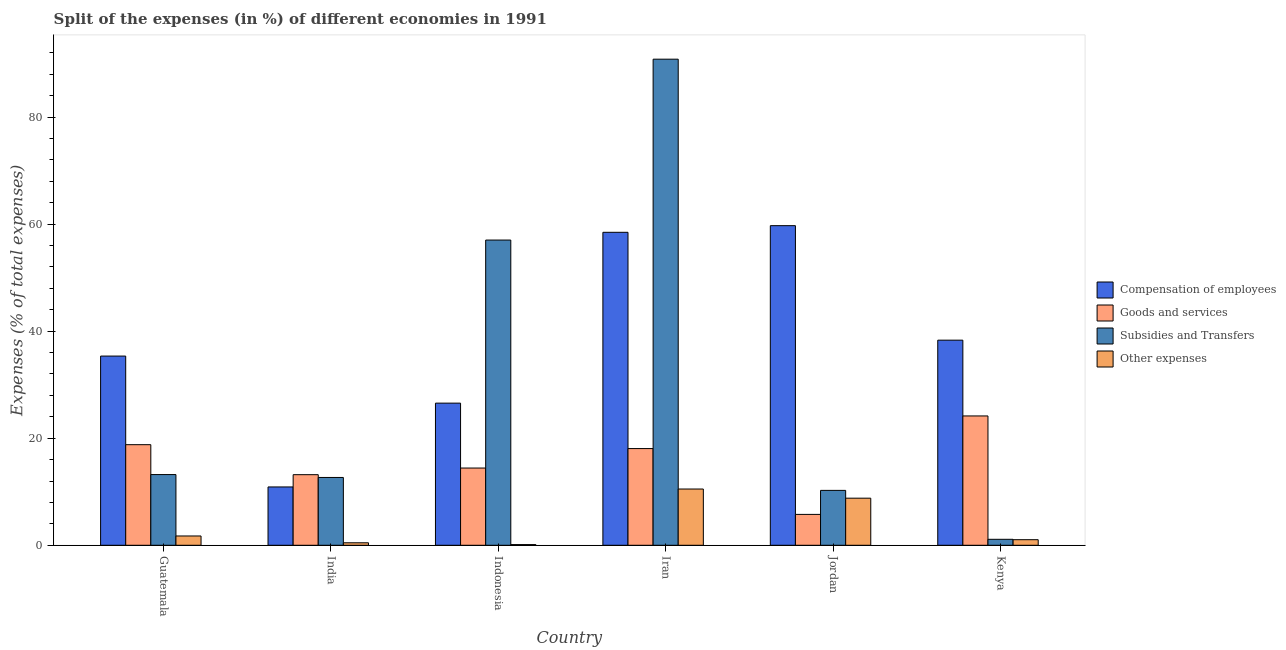How many groups of bars are there?
Provide a short and direct response. 6. How many bars are there on the 1st tick from the left?
Offer a terse response. 4. How many bars are there on the 3rd tick from the right?
Keep it short and to the point. 4. What is the label of the 6th group of bars from the left?
Your response must be concise. Kenya. What is the percentage of amount spent on subsidies in Guatemala?
Give a very brief answer. 13.21. Across all countries, what is the maximum percentage of amount spent on goods and services?
Your answer should be compact. 24.16. Across all countries, what is the minimum percentage of amount spent on other expenses?
Provide a succinct answer. 0.13. In which country was the percentage of amount spent on compensation of employees maximum?
Keep it short and to the point. Jordan. In which country was the percentage of amount spent on subsidies minimum?
Your response must be concise. Kenya. What is the total percentage of amount spent on other expenses in the graph?
Provide a succinct answer. 22.68. What is the difference between the percentage of amount spent on subsidies in Jordan and that in Kenya?
Your response must be concise. 9.14. What is the difference between the percentage of amount spent on goods and services in Indonesia and the percentage of amount spent on other expenses in Jordan?
Your response must be concise. 5.63. What is the average percentage of amount spent on subsidies per country?
Offer a terse response. 30.84. What is the difference between the percentage of amount spent on subsidies and percentage of amount spent on other expenses in Iran?
Your response must be concise. 80.3. What is the ratio of the percentage of amount spent on compensation of employees in Guatemala to that in Indonesia?
Offer a terse response. 1.33. Is the difference between the percentage of amount spent on goods and services in Indonesia and Jordan greater than the difference between the percentage of amount spent on compensation of employees in Indonesia and Jordan?
Provide a succinct answer. Yes. What is the difference between the highest and the second highest percentage of amount spent on other expenses?
Ensure brevity in your answer.  1.71. What is the difference between the highest and the lowest percentage of amount spent on compensation of employees?
Make the answer very short. 48.81. In how many countries, is the percentage of amount spent on other expenses greater than the average percentage of amount spent on other expenses taken over all countries?
Ensure brevity in your answer.  2. Is it the case that in every country, the sum of the percentage of amount spent on compensation of employees and percentage of amount spent on subsidies is greater than the sum of percentage of amount spent on other expenses and percentage of amount spent on goods and services?
Offer a very short reply. No. What does the 1st bar from the left in India represents?
Provide a succinct answer. Compensation of employees. What does the 3rd bar from the right in Indonesia represents?
Offer a very short reply. Goods and services. Is it the case that in every country, the sum of the percentage of amount spent on compensation of employees and percentage of amount spent on goods and services is greater than the percentage of amount spent on subsidies?
Provide a succinct answer. No. How many bars are there?
Make the answer very short. 24. Are all the bars in the graph horizontal?
Your response must be concise. No. What is the difference between two consecutive major ticks on the Y-axis?
Keep it short and to the point. 20. Does the graph contain any zero values?
Ensure brevity in your answer.  No. Does the graph contain grids?
Offer a very short reply. No. Where does the legend appear in the graph?
Provide a short and direct response. Center right. How many legend labels are there?
Your response must be concise. 4. How are the legend labels stacked?
Your response must be concise. Vertical. What is the title of the graph?
Give a very brief answer. Split of the expenses (in %) of different economies in 1991. Does "Source data assessment" appear as one of the legend labels in the graph?
Make the answer very short. No. What is the label or title of the X-axis?
Ensure brevity in your answer.  Country. What is the label or title of the Y-axis?
Keep it short and to the point. Expenses (% of total expenses). What is the Expenses (% of total expenses) in Compensation of employees in Guatemala?
Give a very brief answer. 35.34. What is the Expenses (% of total expenses) of Goods and services in Guatemala?
Your response must be concise. 18.79. What is the Expenses (% of total expenses) of Subsidies and Transfers in Guatemala?
Offer a terse response. 13.21. What is the Expenses (% of total expenses) in Other expenses in Guatemala?
Keep it short and to the point. 1.74. What is the Expenses (% of total expenses) of Compensation of employees in India?
Your response must be concise. 10.9. What is the Expenses (% of total expenses) of Goods and services in India?
Give a very brief answer. 13.19. What is the Expenses (% of total expenses) in Subsidies and Transfers in India?
Provide a succinct answer. 12.67. What is the Expenses (% of total expenses) in Other expenses in India?
Keep it short and to the point. 0.46. What is the Expenses (% of total expenses) of Compensation of employees in Indonesia?
Keep it short and to the point. 26.55. What is the Expenses (% of total expenses) of Goods and services in Indonesia?
Give a very brief answer. 14.43. What is the Expenses (% of total expenses) in Subsidies and Transfers in Indonesia?
Ensure brevity in your answer.  57.02. What is the Expenses (% of total expenses) in Other expenses in Indonesia?
Make the answer very short. 0.13. What is the Expenses (% of total expenses) in Compensation of employees in Iran?
Provide a succinct answer. 58.46. What is the Expenses (% of total expenses) of Goods and services in Iran?
Provide a succinct answer. 18.07. What is the Expenses (% of total expenses) of Subsidies and Transfers in Iran?
Ensure brevity in your answer.  90.8. What is the Expenses (% of total expenses) in Other expenses in Iran?
Provide a succinct answer. 10.51. What is the Expenses (% of total expenses) in Compensation of employees in Jordan?
Offer a terse response. 59.7. What is the Expenses (% of total expenses) in Goods and services in Jordan?
Offer a terse response. 5.77. What is the Expenses (% of total expenses) in Subsidies and Transfers in Jordan?
Provide a short and direct response. 10.25. What is the Expenses (% of total expenses) of Other expenses in Jordan?
Your response must be concise. 8.8. What is the Expenses (% of total expenses) in Compensation of employees in Kenya?
Make the answer very short. 38.32. What is the Expenses (% of total expenses) in Goods and services in Kenya?
Your answer should be compact. 24.16. What is the Expenses (% of total expenses) of Subsidies and Transfers in Kenya?
Provide a short and direct response. 1.12. What is the Expenses (% of total expenses) of Other expenses in Kenya?
Give a very brief answer. 1.04. Across all countries, what is the maximum Expenses (% of total expenses) in Compensation of employees?
Make the answer very short. 59.7. Across all countries, what is the maximum Expenses (% of total expenses) of Goods and services?
Make the answer very short. 24.16. Across all countries, what is the maximum Expenses (% of total expenses) in Subsidies and Transfers?
Offer a terse response. 90.8. Across all countries, what is the maximum Expenses (% of total expenses) of Other expenses?
Provide a short and direct response. 10.51. Across all countries, what is the minimum Expenses (% of total expenses) in Compensation of employees?
Provide a short and direct response. 10.9. Across all countries, what is the minimum Expenses (% of total expenses) of Goods and services?
Your answer should be very brief. 5.77. Across all countries, what is the minimum Expenses (% of total expenses) of Subsidies and Transfers?
Your response must be concise. 1.12. Across all countries, what is the minimum Expenses (% of total expenses) of Other expenses?
Your answer should be compact. 0.13. What is the total Expenses (% of total expenses) in Compensation of employees in the graph?
Provide a short and direct response. 229.28. What is the total Expenses (% of total expenses) in Goods and services in the graph?
Your response must be concise. 94.4. What is the total Expenses (% of total expenses) in Subsidies and Transfers in the graph?
Give a very brief answer. 185.06. What is the total Expenses (% of total expenses) of Other expenses in the graph?
Your answer should be very brief. 22.68. What is the difference between the Expenses (% of total expenses) of Compensation of employees in Guatemala and that in India?
Make the answer very short. 24.45. What is the difference between the Expenses (% of total expenses) of Goods and services in Guatemala and that in India?
Your answer should be very brief. 5.6. What is the difference between the Expenses (% of total expenses) of Subsidies and Transfers in Guatemala and that in India?
Your response must be concise. 0.54. What is the difference between the Expenses (% of total expenses) of Other expenses in Guatemala and that in India?
Provide a succinct answer. 1.27. What is the difference between the Expenses (% of total expenses) of Compensation of employees in Guatemala and that in Indonesia?
Make the answer very short. 8.79. What is the difference between the Expenses (% of total expenses) in Goods and services in Guatemala and that in Indonesia?
Provide a short and direct response. 4.36. What is the difference between the Expenses (% of total expenses) of Subsidies and Transfers in Guatemala and that in Indonesia?
Ensure brevity in your answer.  -43.81. What is the difference between the Expenses (% of total expenses) of Other expenses in Guatemala and that in Indonesia?
Make the answer very short. 1.61. What is the difference between the Expenses (% of total expenses) of Compensation of employees in Guatemala and that in Iran?
Offer a terse response. -23.12. What is the difference between the Expenses (% of total expenses) in Goods and services in Guatemala and that in Iran?
Make the answer very short. 0.73. What is the difference between the Expenses (% of total expenses) in Subsidies and Transfers in Guatemala and that in Iran?
Your answer should be very brief. -77.6. What is the difference between the Expenses (% of total expenses) of Other expenses in Guatemala and that in Iran?
Offer a very short reply. -8.77. What is the difference between the Expenses (% of total expenses) in Compensation of employees in Guatemala and that in Jordan?
Give a very brief answer. -24.36. What is the difference between the Expenses (% of total expenses) in Goods and services in Guatemala and that in Jordan?
Offer a terse response. 13.02. What is the difference between the Expenses (% of total expenses) in Subsidies and Transfers in Guatemala and that in Jordan?
Keep it short and to the point. 2.95. What is the difference between the Expenses (% of total expenses) in Other expenses in Guatemala and that in Jordan?
Make the answer very short. -7.06. What is the difference between the Expenses (% of total expenses) in Compensation of employees in Guatemala and that in Kenya?
Offer a very short reply. -2.97. What is the difference between the Expenses (% of total expenses) of Goods and services in Guatemala and that in Kenya?
Provide a short and direct response. -5.37. What is the difference between the Expenses (% of total expenses) of Subsidies and Transfers in Guatemala and that in Kenya?
Give a very brief answer. 12.09. What is the difference between the Expenses (% of total expenses) in Other expenses in Guatemala and that in Kenya?
Offer a very short reply. 0.7. What is the difference between the Expenses (% of total expenses) in Compensation of employees in India and that in Indonesia?
Give a very brief answer. -15.66. What is the difference between the Expenses (% of total expenses) of Goods and services in India and that in Indonesia?
Give a very brief answer. -1.24. What is the difference between the Expenses (% of total expenses) in Subsidies and Transfers in India and that in Indonesia?
Offer a terse response. -44.35. What is the difference between the Expenses (% of total expenses) in Other expenses in India and that in Indonesia?
Keep it short and to the point. 0.33. What is the difference between the Expenses (% of total expenses) of Compensation of employees in India and that in Iran?
Ensure brevity in your answer.  -47.57. What is the difference between the Expenses (% of total expenses) of Goods and services in India and that in Iran?
Provide a short and direct response. -4.88. What is the difference between the Expenses (% of total expenses) of Subsidies and Transfers in India and that in Iran?
Provide a succinct answer. -78.14. What is the difference between the Expenses (% of total expenses) in Other expenses in India and that in Iran?
Your answer should be very brief. -10.05. What is the difference between the Expenses (% of total expenses) of Compensation of employees in India and that in Jordan?
Your answer should be very brief. -48.81. What is the difference between the Expenses (% of total expenses) of Goods and services in India and that in Jordan?
Your response must be concise. 7.42. What is the difference between the Expenses (% of total expenses) in Subsidies and Transfers in India and that in Jordan?
Offer a very short reply. 2.42. What is the difference between the Expenses (% of total expenses) of Other expenses in India and that in Jordan?
Provide a short and direct response. -8.34. What is the difference between the Expenses (% of total expenses) of Compensation of employees in India and that in Kenya?
Your answer should be compact. -27.42. What is the difference between the Expenses (% of total expenses) of Goods and services in India and that in Kenya?
Offer a terse response. -10.97. What is the difference between the Expenses (% of total expenses) in Subsidies and Transfers in India and that in Kenya?
Provide a short and direct response. 11.55. What is the difference between the Expenses (% of total expenses) in Other expenses in India and that in Kenya?
Make the answer very short. -0.58. What is the difference between the Expenses (% of total expenses) of Compensation of employees in Indonesia and that in Iran?
Give a very brief answer. -31.91. What is the difference between the Expenses (% of total expenses) in Goods and services in Indonesia and that in Iran?
Give a very brief answer. -3.64. What is the difference between the Expenses (% of total expenses) of Subsidies and Transfers in Indonesia and that in Iran?
Your response must be concise. -33.79. What is the difference between the Expenses (% of total expenses) of Other expenses in Indonesia and that in Iran?
Your response must be concise. -10.38. What is the difference between the Expenses (% of total expenses) of Compensation of employees in Indonesia and that in Jordan?
Give a very brief answer. -33.15. What is the difference between the Expenses (% of total expenses) in Goods and services in Indonesia and that in Jordan?
Give a very brief answer. 8.66. What is the difference between the Expenses (% of total expenses) of Subsidies and Transfers in Indonesia and that in Jordan?
Offer a very short reply. 46.76. What is the difference between the Expenses (% of total expenses) of Other expenses in Indonesia and that in Jordan?
Ensure brevity in your answer.  -8.67. What is the difference between the Expenses (% of total expenses) in Compensation of employees in Indonesia and that in Kenya?
Offer a very short reply. -11.76. What is the difference between the Expenses (% of total expenses) in Goods and services in Indonesia and that in Kenya?
Your answer should be very brief. -9.73. What is the difference between the Expenses (% of total expenses) in Subsidies and Transfers in Indonesia and that in Kenya?
Make the answer very short. 55.9. What is the difference between the Expenses (% of total expenses) of Other expenses in Indonesia and that in Kenya?
Your answer should be compact. -0.91. What is the difference between the Expenses (% of total expenses) of Compensation of employees in Iran and that in Jordan?
Offer a terse response. -1.24. What is the difference between the Expenses (% of total expenses) of Goods and services in Iran and that in Jordan?
Make the answer very short. 12.3. What is the difference between the Expenses (% of total expenses) of Subsidies and Transfers in Iran and that in Jordan?
Offer a terse response. 80.55. What is the difference between the Expenses (% of total expenses) in Other expenses in Iran and that in Jordan?
Ensure brevity in your answer.  1.71. What is the difference between the Expenses (% of total expenses) of Compensation of employees in Iran and that in Kenya?
Ensure brevity in your answer.  20.15. What is the difference between the Expenses (% of total expenses) in Goods and services in Iran and that in Kenya?
Offer a very short reply. -6.09. What is the difference between the Expenses (% of total expenses) in Subsidies and Transfers in Iran and that in Kenya?
Offer a terse response. 89.69. What is the difference between the Expenses (% of total expenses) in Other expenses in Iran and that in Kenya?
Offer a very short reply. 9.47. What is the difference between the Expenses (% of total expenses) of Compensation of employees in Jordan and that in Kenya?
Your answer should be very brief. 21.39. What is the difference between the Expenses (% of total expenses) of Goods and services in Jordan and that in Kenya?
Give a very brief answer. -18.39. What is the difference between the Expenses (% of total expenses) of Subsidies and Transfers in Jordan and that in Kenya?
Your response must be concise. 9.14. What is the difference between the Expenses (% of total expenses) in Other expenses in Jordan and that in Kenya?
Your response must be concise. 7.76. What is the difference between the Expenses (% of total expenses) of Compensation of employees in Guatemala and the Expenses (% of total expenses) of Goods and services in India?
Ensure brevity in your answer.  22.16. What is the difference between the Expenses (% of total expenses) of Compensation of employees in Guatemala and the Expenses (% of total expenses) of Subsidies and Transfers in India?
Offer a terse response. 22.68. What is the difference between the Expenses (% of total expenses) of Compensation of employees in Guatemala and the Expenses (% of total expenses) of Other expenses in India?
Provide a succinct answer. 34.88. What is the difference between the Expenses (% of total expenses) in Goods and services in Guatemala and the Expenses (% of total expenses) in Subsidies and Transfers in India?
Keep it short and to the point. 6.12. What is the difference between the Expenses (% of total expenses) in Goods and services in Guatemala and the Expenses (% of total expenses) in Other expenses in India?
Ensure brevity in your answer.  18.33. What is the difference between the Expenses (% of total expenses) in Subsidies and Transfers in Guatemala and the Expenses (% of total expenses) in Other expenses in India?
Your answer should be compact. 12.74. What is the difference between the Expenses (% of total expenses) in Compensation of employees in Guatemala and the Expenses (% of total expenses) in Goods and services in Indonesia?
Provide a succinct answer. 20.92. What is the difference between the Expenses (% of total expenses) in Compensation of employees in Guatemala and the Expenses (% of total expenses) in Subsidies and Transfers in Indonesia?
Offer a very short reply. -21.67. What is the difference between the Expenses (% of total expenses) of Compensation of employees in Guatemala and the Expenses (% of total expenses) of Other expenses in Indonesia?
Ensure brevity in your answer.  35.22. What is the difference between the Expenses (% of total expenses) of Goods and services in Guatemala and the Expenses (% of total expenses) of Subsidies and Transfers in Indonesia?
Your answer should be compact. -38.22. What is the difference between the Expenses (% of total expenses) in Goods and services in Guatemala and the Expenses (% of total expenses) in Other expenses in Indonesia?
Keep it short and to the point. 18.66. What is the difference between the Expenses (% of total expenses) in Subsidies and Transfers in Guatemala and the Expenses (% of total expenses) in Other expenses in Indonesia?
Make the answer very short. 13.08. What is the difference between the Expenses (% of total expenses) in Compensation of employees in Guatemala and the Expenses (% of total expenses) in Goods and services in Iran?
Provide a succinct answer. 17.28. What is the difference between the Expenses (% of total expenses) in Compensation of employees in Guatemala and the Expenses (% of total expenses) in Subsidies and Transfers in Iran?
Your answer should be compact. -55.46. What is the difference between the Expenses (% of total expenses) in Compensation of employees in Guatemala and the Expenses (% of total expenses) in Other expenses in Iran?
Offer a terse response. 24.84. What is the difference between the Expenses (% of total expenses) of Goods and services in Guatemala and the Expenses (% of total expenses) of Subsidies and Transfers in Iran?
Your response must be concise. -72.01. What is the difference between the Expenses (% of total expenses) of Goods and services in Guatemala and the Expenses (% of total expenses) of Other expenses in Iran?
Provide a succinct answer. 8.28. What is the difference between the Expenses (% of total expenses) of Subsidies and Transfers in Guatemala and the Expenses (% of total expenses) of Other expenses in Iran?
Provide a short and direct response. 2.7. What is the difference between the Expenses (% of total expenses) of Compensation of employees in Guatemala and the Expenses (% of total expenses) of Goods and services in Jordan?
Offer a terse response. 29.58. What is the difference between the Expenses (% of total expenses) in Compensation of employees in Guatemala and the Expenses (% of total expenses) in Subsidies and Transfers in Jordan?
Keep it short and to the point. 25.09. What is the difference between the Expenses (% of total expenses) of Compensation of employees in Guatemala and the Expenses (% of total expenses) of Other expenses in Jordan?
Ensure brevity in your answer.  26.55. What is the difference between the Expenses (% of total expenses) in Goods and services in Guatemala and the Expenses (% of total expenses) in Subsidies and Transfers in Jordan?
Your answer should be very brief. 8.54. What is the difference between the Expenses (% of total expenses) of Goods and services in Guatemala and the Expenses (% of total expenses) of Other expenses in Jordan?
Give a very brief answer. 9.99. What is the difference between the Expenses (% of total expenses) of Subsidies and Transfers in Guatemala and the Expenses (% of total expenses) of Other expenses in Jordan?
Your answer should be compact. 4.41. What is the difference between the Expenses (% of total expenses) in Compensation of employees in Guatemala and the Expenses (% of total expenses) in Goods and services in Kenya?
Provide a short and direct response. 11.18. What is the difference between the Expenses (% of total expenses) in Compensation of employees in Guatemala and the Expenses (% of total expenses) in Subsidies and Transfers in Kenya?
Your answer should be very brief. 34.23. What is the difference between the Expenses (% of total expenses) of Compensation of employees in Guatemala and the Expenses (% of total expenses) of Other expenses in Kenya?
Provide a short and direct response. 34.3. What is the difference between the Expenses (% of total expenses) in Goods and services in Guatemala and the Expenses (% of total expenses) in Subsidies and Transfers in Kenya?
Keep it short and to the point. 17.68. What is the difference between the Expenses (% of total expenses) in Goods and services in Guatemala and the Expenses (% of total expenses) in Other expenses in Kenya?
Your answer should be very brief. 17.75. What is the difference between the Expenses (% of total expenses) of Subsidies and Transfers in Guatemala and the Expenses (% of total expenses) of Other expenses in Kenya?
Ensure brevity in your answer.  12.17. What is the difference between the Expenses (% of total expenses) in Compensation of employees in India and the Expenses (% of total expenses) in Goods and services in Indonesia?
Give a very brief answer. -3.53. What is the difference between the Expenses (% of total expenses) of Compensation of employees in India and the Expenses (% of total expenses) of Subsidies and Transfers in Indonesia?
Your answer should be compact. -46.12. What is the difference between the Expenses (% of total expenses) of Compensation of employees in India and the Expenses (% of total expenses) of Other expenses in Indonesia?
Make the answer very short. 10.77. What is the difference between the Expenses (% of total expenses) in Goods and services in India and the Expenses (% of total expenses) in Subsidies and Transfers in Indonesia?
Offer a terse response. -43.83. What is the difference between the Expenses (% of total expenses) in Goods and services in India and the Expenses (% of total expenses) in Other expenses in Indonesia?
Your answer should be compact. 13.06. What is the difference between the Expenses (% of total expenses) in Subsidies and Transfers in India and the Expenses (% of total expenses) in Other expenses in Indonesia?
Give a very brief answer. 12.54. What is the difference between the Expenses (% of total expenses) in Compensation of employees in India and the Expenses (% of total expenses) in Goods and services in Iran?
Ensure brevity in your answer.  -7.17. What is the difference between the Expenses (% of total expenses) of Compensation of employees in India and the Expenses (% of total expenses) of Subsidies and Transfers in Iran?
Offer a very short reply. -79.91. What is the difference between the Expenses (% of total expenses) of Compensation of employees in India and the Expenses (% of total expenses) of Other expenses in Iran?
Give a very brief answer. 0.39. What is the difference between the Expenses (% of total expenses) of Goods and services in India and the Expenses (% of total expenses) of Subsidies and Transfers in Iran?
Provide a succinct answer. -77.62. What is the difference between the Expenses (% of total expenses) of Goods and services in India and the Expenses (% of total expenses) of Other expenses in Iran?
Offer a terse response. 2.68. What is the difference between the Expenses (% of total expenses) in Subsidies and Transfers in India and the Expenses (% of total expenses) in Other expenses in Iran?
Offer a very short reply. 2.16. What is the difference between the Expenses (% of total expenses) in Compensation of employees in India and the Expenses (% of total expenses) in Goods and services in Jordan?
Your answer should be compact. 5.13. What is the difference between the Expenses (% of total expenses) of Compensation of employees in India and the Expenses (% of total expenses) of Subsidies and Transfers in Jordan?
Provide a short and direct response. 0.64. What is the difference between the Expenses (% of total expenses) in Compensation of employees in India and the Expenses (% of total expenses) in Other expenses in Jordan?
Ensure brevity in your answer.  2.1. What is the difference between the Expenses (% of total expenses) in Goods and services in India and the Expenses (% of total expenses) in Subsidies and Transfers in Jordan?
Give a very brief answer. 2.94. What is the difference between the Expenses (% of total expenses) in Goods and services in India and the Expenses (% of total expenses) in Other expenses in Jordan?
Provide a succinct answer. 4.39. What is the difference between the Expenses (% of total expenses) of Subsidies and Transfers in India and the Expenses (% of total expenses) of Other expenses in Jordan?
Give a very brief answer. 3.87. What is the difference between the Expenses (% of total expenses) of Compensation of employees in India and the Expenses (% of total expenses) of Goods and services in Kenya?
Offer a very short reply. -13.26. What is the difference between the Expenses (% of total expenses) in Compensation of employees in India and the Expenses (% of total expenses) in Subsidies and Transfers in Kenya?
Your answer should be very brief. 9.78. What is the difference between the Expenses (% of total expenses) of Compensation of employees in India and the Expenses (% of total expenses) of Other expenses in Kenya?
Offer a terse response. 9.86. What is the difference between the Expenses (% of total expenses) of Goods and services in India and the Expenses (% of total expenses) of Subsidies and Transfers in Kenya?
Keep it short and to the point. 12.07. What is the difference between the Expenses (% of total expenses) in Goods and services in India and the Expenses (% of total expenses) in Other expenses in Kenya?
Ensure brevity in your answer.  12.15. What is the difference between the Expenses (% of total expenses) of Subsidies and Transfers in India and the Expenses (% of total expenses) of Other expenses in Kenya?
Your response must be concise. 11.63. What is the difference between the Expenses (% of total expenses) in Compensation of employees in Indonesia and the Expenses (% of total expenses) in Goods and services in Iran?
Keep it short and to the point. 8.49. What is the difference between the Expenses (% of total expenses) of Compensation of employees in Indonesia and the Expenses (% of total expenses) of Subsidies and Transfers in Iran?
Your answer should be very brief. -64.25. What is the difference between the Expenses (% of total expenses) of Compensation of employees in Indonesia and the Expenses (% of total expenses) of Other expenses in Iran?
Offer a very short reply. 16.04. What is the difference between the Expenses (% of total expenses) of Goods and services in Indonesia and the Expenses (% of total expenses) of Subsidies and Transfers in Iran?
Ensure brevity in your answer.  -76.38. What is the difference between the Expenses (% of total expenses) of Goods and services in Indonesia and the Expenses (% of total expenses) of Other expenses in Iran?
Your response must be concise. 3.92. What is the difference between the Expenses (% of total expenses) in Subsidies and Transfers in Indonesia and the Expenses (% of total expenses) in Other expenses in Iran?
Keep it short and to the point. 46.51. What is the difference between the Expenses (% of total expenses) of Compensation of employees in Indonesia and the Expenses (% of total expenses) of Goods and services in Jordan?
Provide a short and direct response. 20.78. What is the difference between the Expenses (% of total expenses) of Compensation of employees in Indonesia and the Expenses (% of total expenses) of Subsidies and Transfers in Jordan?
Provide a short and direct response. 16.3. What is the difference between the Expenses (% of total expenses) in Compensation of employees in Indonesia and the Expenses (% of total expenses) in Other expenses in Jordan?
Provide a short and direct response. 17.75. What is the difference between the Expenses (% of total expenses) of Goods and services in Indonesia and the Expenses (% of total expenses) of Subsidies and Transfers in Jordan?
Provide a succinct answer. 4.18. What is the difference between the Expenses (% of total expenses) of Goods and services in Indonesia and the Expenses (% of total expenses) of Other expenses in Jordan?
Your answer should be compact. 5.63. What is the difference between the Expenses (% of total expenses) of Subsidies and Transfers in Indonesia and the Expenses (% of total expenses) of Other expenses in Jordan?
Offer a very short reply. 48.22. What is the difference between the Expenses (% of total expenses) in Compensation of employees in Indonesia and the Expenses (% of total expenses) in Goods and services in Kenya?
Offer a very short reply. 2.39. What is the difference between the Expenses (% of total expenses) of Compensation of employees in Indonesia and the Expenses (% of total expenses) of Subsidies and Transfers in Kenya?
Provide a short and direct response. 25.44. What is the difference between the Expenses (% of total expenses) in Compensation of employees in Indonesia and the Expenses (% of total expenses) in Other expenses in Kenya?
Ensure brevity in your answer.  25.51. What is the difference between the Expenses (% of total expenses) of Goods and services in Indonesia and the Expenses (% of total expenses) of Subsidies and Transfers in Kenya?
Give a very brief answer. 13.31. What is the difference between the Expenses (% of total expenses) of Goods and services in Indonesia and the Expenses (% of total expenses) of Other expenses in Kenya?
Give a very brief answer. 13.39. What is the difference between the Expenses (% of total expenses) of Subsidies and Transfers in Indonesia and the Expenses (% of total expenses) of Other expenses in Kenya?
Provide a short and direct response. 55.97. What is the difference between the Expenses (% of total expenses) in Compensation of employees in Iran and the Expenses (% of total expenses) in Goods and services in Jordan?
Your response must be concise. 52.69. What is the difference between the Expenses (% of total expenses) in Compensation of employees in Iran and the Expenses (% of total expenses) in Subsidies and Transfers in Jordan?
Provide a succinct answer. 48.21. What is the difference between the Expenses (% of total expenses) in Compensation of employees in Iran and the Expenses (% of total expenses) in Other expenses in Jordan?
Give a very brief answer. 49.66. What is the difference between the Expenses (% of total expenses) in Goods and services in Iran and the Expenses (% of total expenses) in Subsidies and Transfers in Jordan?
Provide a short and direct response. 7.81. What is the difference between the Expenses (% of total expenses) in Goods and services in Iran and the Expenses (% of total expenses) in Other expenses in Jordan?
Your answer should be very brief. 9.27. What is the difference between the Expenses (% of total expenses) in Subsidies and Transfers in Iran and the Expenses (% of total expenses) in Other expenses in Jordan?
Make the answer very short. 82.01. What is the difference between the Expenses (% of total expenses) of Compensation of employees in Iran and the Expenses (% of total expenses) of Goods and services in Kenya?
Make the answer very short. 34.3. What is the difference between the Expenses (% of total expenses) of Compensation of employees in Iran and the Expenses (% of total expenses) of Subsidies and Transfers in Kenya?
Your answer should be very brief. 57.35. What is the difference between the Expenses (% of total expenses) in Compensation of employees in Iran and the Expenses (% of total expenses) in Other expenses in Kenya?
Keep it short and to the point. 57.42. What is the difference between the Expenses (% of total expenses) of Goods and services in Iran and the Expenses (% of total expenses) of Subsidies and Transfers in Kenya?
Offer a very short reply. 16.95. What is the difference between the Expenses (% of total expenses) in Goods and services in Iran and the Expenses (% of total expenses) in Other expenses in Kenya?
Give a very brief answer. 17.02. What is the difference between the Expenses (% of total expenses) in Subsidies and Transfers in Iran and the Expenses (% of total expenses) in Other expenses in Kenya?
Give a very brief answer. 89.76. What is the difference between the Expenses (% of total expenses) of Compensation of employees in Jordan and the Expenses (% of total expenses) of Goods and services in Kenya?
Provide a short and direct response. 35.54. What is the difference between the Expenses (% of total expenses) of Compensation of employees in Jordan and the Expenses (% of total expenses) of Subsidies and Transfers in Kenya?
Make the answer very short. 58.59. What is the difference between the Expenses (% of total expenses) in Compensation of employees in Jordan and the Expenses (% of total expenses) in Other expenses in Kenya?
Give a very brief answer. 58.66. What is the difference between the Expenses (% of total expenses) of Goods and services in Jordan and the Expenses (% of total expenses) of Subsidies and Transfers in Kenya?
Give a very brief answer. 4.65. What is the difference between the Expenses (% of total expenses) in Goods and services in Jordan and the Expenses (% of total expenses) in Other expenses in Kenya?
Provide a succinct answer. 4.73. What is the difference between the Expenses (% of total expenses) of Subsidies and Transfers in Jordan and the Expenses (% of total expenses) of Other expenses in Kenya?
Offer a very short reply. 9.21. What is the average Expenses (% of total expenses) of Compensation of employees per country?
Offer a very short reply. 38.21. What is the average Expenses (% of total expenses) in Goods and services per country?
Your answer should be compact. 15.73. What is the average Expenses (% of total expenses) in Subsidies and Transfers per country?
Offer a terse response. 30.84. What is the average Expenses (% of total expenses) in Other expenses per country?
Provide a short and direct response. 3.78. What is the difference between the Expenses (% of total expenses) of Compensation of employees and Expenses (% of total expenses) of Goods and services in Guatemala?
Provide a short and direct response. 16.55. What is the difference between the Expenses (% of total expenses) in Compensation of employees and Expenses (% of total expenses) in Subsidies and Transfers in Guatemala?
Keep it short and to the point. 22.14. What is the difference between the Expenses (% of total expenses) in Compensation of employees and Expenses (% of total expenses) in Other expenses in Guatemala?
Provide a succinct answer. 33.61. What is the difference between the Expenses (% of total expenses) of Goods and services and Expenses (% of total expenses) of Subsidies and Transfers in Guatemala?
Provide a succinct answer. 5.59. What is the difference between the Expenses (% of total expenses) of Goods and services and Expenses (% of total expenses) of Other expenses in Guatemala?
Your answer should be very brief. 17.05. What is the difference between the Expenses (% of total expenses) of Subsidies and Transfers and Expenses (% of total expenses) of Other expenses in Guatemala?
Your answer should be compact. 11.47. What is the difference between the Expenses (% of total expenses) of Compensation of employees and Expenses (% of total expenses) of Goods and services in India?
Provide a short and direct response. -2.29. What is the difference between the Expenses (% of total expenses) of Compensation of employees and Expenses (% of total expenses) of Subsidies and Transfers in India?
Your answer should be compact. -1.77. What is the difference between the Expenses (% of total expenses) in Compensation of employees and Expenses (% of total expenses) in Other expenses in India?
Your response must be concise. 10.43. What is the difference between the Expenses (% of total expenses) in Goods and services and Expenses (% of total expenses) in Subsidies and Transfers in India?
Ensure brevity in your answer.  0.52. What is the difference between the Expenses (% of total expenses) in Goods and services and Expenses (% of total expenses) in Other expenses in India?
Make the answer very short. 12.72. What is the difference between the Expenses (% of total expenses) of Subsidies and Transfers and Expenses (% of total expenses) of Other expenses in India?
Keep it short and to the point. 12.21. What is the difference between the Expenses (% of total expenses) in Compensation of employees and Expenses (% of total expenses) in Goods and services in Indonesia?
Offer a very short reply. 12.12. What is the difference between the Expenses (% of total expenses) of Compensation of employees and Expenses (% of total expenses) of Subsidies and Transfers in Indonesia?
Give a very brief answer. -30.46. What is the difference between the Expenses (% of total expenses) in Compensation of employees and Expenses (% of total expenses) in Other expenses in Indonesia?
Provide a succinct answer. 26.42. What is the difference between the Expenses (% of total expenses) of Goods and services and Expenses (% of total expenses) of Subsidies and Transfers in Indonesia?
Keep it short and to the point. -42.59. What is the difference between the Expenses (% of total expenses) of Goods and services and Expenses (% of total expenses) of Other expenses in Indonesia?
Give a very brief answer. 14.3. What is the difference between the Expenses (% of total expenses) in Subsidies and Transfers and Expenses (% of total expenses) in Other expenses in Indonesia?
Make the answer very short. 56.89. What is the difference between the Expenses (% of total expenses) in Compensation of employees and Expenses (% of total expenses) in Goods and services in Iran?
Provide a short and direct response. 40.4. What is the difference between the Expenses (% of total expenses) of Compensation of employees and Expenses (% of total expenses) of Subsidies and Transfers in Iran?
Make the answer very short. -32.34. What is the difference between the Expenses (% of total expenses) in Compensation of employees and Expenses (% of total expenses) in Other expenses in Iran?
Your answer should be compact. 47.95. What is the difference between the Expenses (% of total expenses) in Goods and services and Expenses (% of total expenses) in Subsidies and Transfers in Iran?
Provide a succinct answer. -72.74. What is the difference between the Expenses (% of total expenses) of Goods and services and Expenses (% of total expenses) of Other expenses in Iran?
Provide a short and direct response. 7.56. What is the difference between the Expenses (% of total expenses) in Subsidies and Transfers and Expenses (% of total expenses) in Other expenses in Iran?
Provide a succinct answer. 80.3. What is the difference between the Expenses (% of total expenses) in Compensation of employees and Expenses (% of total expenses) in Goods and services in Jordan?
Keep it short and to the point. 53.94. What is the difference between the Expenses (% of total expenses) in Compensation of employees and Expenses (% of total expenses) in Subsidies and Transfers in Jordan?
Ensure brevity in your answer.  49.45. What is the difference between the Expenses (% of total expenses) in Compensation of employees and Expenses (% of total expenses) in Other expenses in Jordan?
Offer a very short reply. 50.91. What is the difference between the Expenses (% of total expenses) in Goods and services and Expenses (% of total expenses) in Subsidies and Transfers in Jordan?
Your answer should be very brief. -4.48. What is the difference between the Expenses (% of total expenses) in Goods and services and Expenses (% of total expenses) in Other expenses in Jordan?
Provide a succinct answer. -3.03. What is the difference between the Expenses (% of total expenses) of Subsidies and Transfers and Expenses (% of total expenses) of Other expenses in Jordan?
Your answer should be very brief. 1.45. What is the difference between the Expenses (% of total expenses) of Compensation of employees and Expenses (% of total expenses) of Goods and services in Kenya?
Offer a very short reply. 14.16. What is the difference between the Expenses (% of total expenses) of Compensation of employees and Expenses (% of total expenses) of Subsidies and Transfers in Kenya?
Your answer should be compact. 37.2. What is the difference between the Expenses (% of total expenses) in Compensation of employees and Expenses (% of total expenses) in Other expenses in Kenya?
Your answer should be very brief. 37.27. What is the difference between the Expenses (% of total expenses) of Goods and services and Expenses (% of total expenses) of Subsidies and Transfers in Kenya?
Give a very brief answer. 23.04. What is the difference between the Expenses (% of total expenses) of Goods and services and Expenses (% of total expenses) of Other expenses in Kenya?
Your answer should be very brief. 23.12. What is the difference between the Expenses (% of total expenses) in Subsidies and Transfers and Expenses (% of total expenses) in Other expenses in Kenya?
Your answer should be very brief. 0.07. What is the ratio of the Expenses (% of total expenses) of Compensation of employees in Guatemala to that in India?
Make the answer very short. 3.24. What is the ratio of the Expenses (% of total expenses) of Goods and services in Guatemala to that in India?
Keep it short and to the point. 1.42. What is the ratio of the Expenses (% of total expenses) in Subsidies and Transfers in Guatemala to that in India?
Your answer should be compact. 1.04. What is the ratio of the Expenses (% of total expenses) in Other expenses in Guatemala to that in India?
Your response must be concise. 3.75. What is the ratio of the Expenses (% of total expenses) in Compensation of employees in Guatemala to that in Indonesia?
Your response must be concise. 1.33. What is the ratio of the Expenses (% of total expenses) in Goods and services in Guatemala to that in Indonesia?
Your answer should be very brief. 1.3. What is the ratio of the Expenses (% of total expenses) of Subsidies and Transfers in Guatemala to that in Indonesia?
Provide a succinct answer. 0.23. What is the ratio of the Expenses (% of total expenses) in Other expenses in Guatemala to that in Indonesia?
Make the answer very short. 13.52. What is the ratio of the Expenses (% of total expenses) of Compensation of employees in Guatemala to that in Iran?
Your answer should be very brief. 0.6. What is the ratio of the Expenses (% of total expenses) of Goods and services in Guatemala to that in Iran?
Your answer should be compact. 1.04. What is the ratio of the Expenses (% of total expenses) of Subsidies and Transfers in Guatemala to that in Iran?
Your response must be concise. 0.15. What is the ratio of the Expenses (% of total expenses) in Other expenses in Guatemala to that in Iran?
Provide a succinct answer. 0.17. What is the ratio of the Expenses (% of total expenses) of Compensation of employees in Guatemala to that in Jordan?
Offer a terse response. 0.59. What is the ratio of the Expenses (% of total expenses) of Goods and services in Guatemala to that in Jordan?
Your response must be concise. 3.26. What is the ratio of the Expenses (% of total expenses) in Subsidies and Transfers in Guatemala to that in Jordan?
Make the answer very short. 1.29. What is the ratio of the Expenses (% of total expenses) of Other expenses in Guatemala to that in Jordan?
Offer a very short reply. 0.2. What is the ratio of the Expenses (% of total expenses) in Compensation of employees in Guatemala to that in Kenya?
Make the answer very short. 0.92. What is the ratio of the Expenses (% of total expenses) of Subsidies and Transfers in Guatemala to that in Kenya?
Provide a succinct answer. 11.83. What is the ratio of the Expenses (% of total expenses) in Other expenses in Guatemala to that in Kenya?
Provide a short and direct response. 1.67. What is the ratio of the Expenses (% of total expenses) of Compensation of employees in India to that in Indonesia?
Ensure brevity in your answer.  0.41. What is the ratio of the Expenses (% of total expenses) in Goods and services in India to that in Indonesia?
Provide a succinct answer. 0.91. What is the ratio of the Expenses (% of total expenses) in Subsidies and Transfers in India to that in Indonesia?
Offer a very short reply. 0.22. What is the ratio of the Expenses (% of total expenses) in Other expenses in India to that in Indonesia?
Offer a terse response. 3.61. What is the ratio of the Expenses (% of total expenses) in Compensation of employees in India to that in Iran?
Offer a very short reply. 0.19. What is the ratio of the Expenses (% of total expenses) of Goods and services in India to that in Iran?
Your response must be concise. 0.73. What is the ratio of the Expenses (% of total expenses) of Subsidies and Transfers in India to that in Iran?
Ensure brevity in your answer.  0.14. What is the ratio of the Expenses (% of total expenses) in Other expenses in India to that in Iran?
Provide a succinct answer. 0.04. What is the ratio of the Expenses (% of total expenses) of Compensation of employees in India to that in Jordan?
Make the answer very short. 0.18. What is the ratio of the Expenses (% of total expenses) in Goods and services in India to that in Jordan?
Give a very brief answer. 2.29. What is the ratio of the Expenses (% of total expenses) in Subsidies and Transfers in India to that in Jordan?
Your answer should be compact. 1.24. What is the ratio of the Expenses (% of total expenses) in Other expenses in India to that in Jordan?
Make the answer very short. 0.05. What is the ratio of the Expenses (% of total expenses) of Compensation of employees in India to that in Kenya?
Give a very brief answer. 0.28. What is the ratio of the Expenses (% of total expenses) in Goods and services in India to that in Kenya?
Your answer should be very brief. 0.55. What is the ratio of the Expenses (% of total expenses) in Subsidies and Transfers in India to that in Kenya?
Ensure brevity in your answer.  11.35. What is the ratio of the Expenses (% of total expenses) of Other expenses in India to that in Kenya?
Ensure brevity in your answer.  0.44. What is the ratio of the Expenses (% of total expenses) in Compensation of employees in Indonesia to that in Iran?
Provide a short and direct response. 0.45. What is the ratio of the Expenses (% of total expenses) of Goods and services in Indonesia to that in Iran?
Give a very brief answer. 0.8. What is the ratio of the Expenses (% of total expenses) in Subsidies and Transfers in Indonesia to that in Iran?
Keep it short and to the point. 0.63. What is the ratio of the Expenses (% of total expenses) in Other expenses in Indonesia to that in Iran?
Keep it short and to the point. 0.01. What is the ratio of the Expenses (% of total expenses) in Compensation of employees in Indonesia to that in Jordan?
Keep it short and to the point. 0.44. What is the ratio of the Expenses (% of total expenses) of Goods and services in Indonesia to that in Jordan?
Your response must be concise. 2.5. What is the ratio of the Expenses (% of total expenses) of Subsidies and Transfers in Indonesia to that in Jordan?
Make the answer very short. 5.56. What is the ratio of the Expenses (% of total expenses) in Other expenses in Indonesia to that in Jordan?
Provide a succinct answer. 0.01. What is the ratio of the Expenses (% of total expenses) of Compensation of employees in Indonesia to that in Kenya?
Your response must be concise. 0.69. What is the ratio of the Expenses (% of total expenses) in Goods and services in Indonesia to that in Kenya?
Your answer should be very brief. 0.6. What is the ratio of the Expenses (% of total expenses) in Subsidies and Transfers in Indonesia to that in Kenya?
Offer a terse response. 51.09. What is the ratio of the Expenses (% of total expenses) of Other expenses in Indonesia to that in Kenya?
Provide a succinct answer. 0.12. What is the ratio of the Expenses (% of total expenses) in Compensation of employees in Iran to that in Jordan?
Offer a very short reply. 0.98. What is the ratio of the Expenses (% of total expenses) of Goods and services in Iran to that in Jordan?
Your answer should be compact. 3.13. What is the ratio of the Expenses (% of total expenses) of Subsidies and Transfers in Iran to that in Jordan?
Provide a short and direct response. 8.86. What is the ratio of the Expenses (% of total expenses) of Other expenses in Iran to that in Jordan?
Make the answer very short. 1.19. What is the ratio of the Expenses (% of total expenses) in Compensation of employees in Iran to that in Kenya?
Your response must be concise. 1.53. What is the ratio of the Expenses (% of total expenses) in Goods and services in Iran to that in Kenya?
Your answer should be very brief. 0.75. What is the ratio of the Expenses (% of total expenses) in Subsidies and Transfers in Iran to that in Kenya?
Provide a short and direct response. 81.36. What is the ratio of the Expenses (% of total expenses) of Other expenses in Iran to that in Kenya?
Keep it short and to the point. 10.09. What is the ratio of the Expenses (% of total expenses) of Compensation of employees in Jordan to that in Kenya?
Provide a succinct answer. 1.56. What is the ratio of the Expenses (% of total expenses) in Goods and services in Jordan to that in Kenya?
Keep it short and to the point. 0.24. What is the ratio of the Expenses (% of total expenses) of Subsidies and Transfers in Jordan to that in Kenya?
Your answer should be compact. 9.19. What is the ratio of the Expenses (% of total expenses) of Other expenses in Jordan to that in Kenya?
Provide a short and direct response. 8.45. What is the difference between the highest and the second highest Expenses (% of total expenses) in Compensation of employees?
Give a very brief answer. 1.24. What is the difference between the highest and the second highest Expenses (% of total expenses) in Goods and services?
Your answer should be very brief. 5.37. What is the difference between the highest and the second highest Expenses (% of total expenses) in Subsidies and Transfers?
Your response must be concise. 33.79. What is the difference between the highest and the second highest Expenses (% of total expenses) in Other expenses?
Offer a terse response. 1.71. What is the difference between the highest and the lowest Expenses (% of total expenses) of Compensation of employees?
Your answer should be compact. 48.81. What is the difference between the highest and the lowest Expenses (% of total expenses) in Goods and services?
Provide a short and direct response. 18.39. What is the difference between the highest and the lowest Expenses (% of total expenses) of Subsidies and Transfers?
Provide a succinct answer. 89.69. What is the difference between the highest and the lowest Expenses (% of total expenses) in Other expenses?
Ensure brevity in your answer.  10.38. 